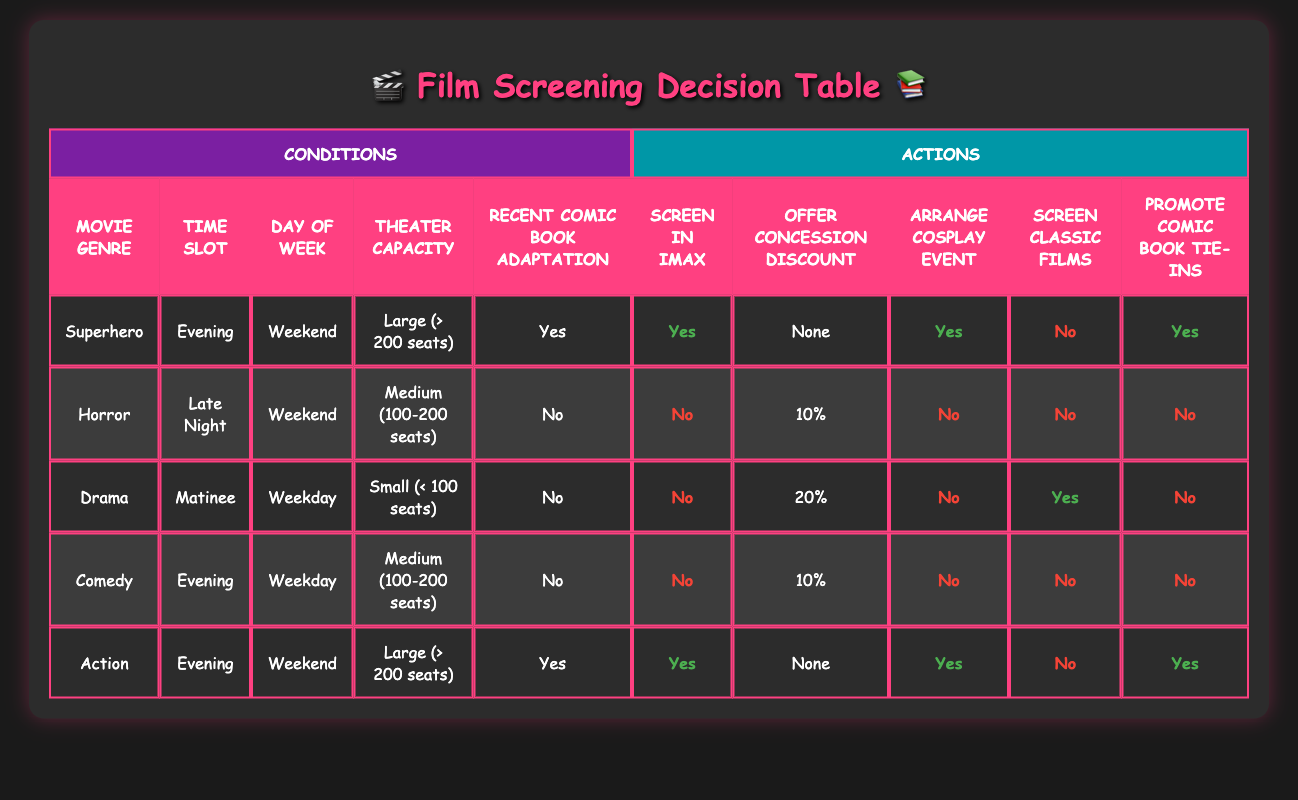What genre of movie is shown in IMAX during the evening on weekends with a recent comic book adaptation? The table shows a row for "Superhero" movies screened in IMAX during the evening on weekends with a recent comic book adaptation. This matches the condition specified in the question.
Answer: Superhero What is the concession discount offered for horror movies screened late at night on weekends? Referring to the row for horror movies, it states that the concession discount offered is 10% for a medium theater capacity and no recent comic book adaptation.
Answer: 10% How many different actions are taken for action movies screened on weekends? The corresponding row for action movies lists four actions: "Screen in IMAX" is Yes, "Offer Concession Discount" is None, "Arrange Cosplay Event" is Yes, and "Promote Comic Book Tie-ins" is Yes. Count these confirmed actions to arrive at the total.
Answer: Four Is there a concession discount offered for drama movies shown during the weekday matinee? Looking at the row for drama movies, it specifies a discount of 20%. Therefore, the answer confirms that there is a concession discount offered.
Answer: Yes What are the conditions for screening classic films during a weekday matinee? Under the conditions for drama movies shown during this time, it is stated that classic films should be screened, which indicates that this condition is satisfied.
Answer: Yes What percentage of the offerings involve screening comic book tie-ins when the movie is an action genre? From the action genre row, it indicates that the screening includes promoting comic book tie-ins. This represents one of the actions out of a total of five actions listed for this genre. Hence the percentage is calculated as (1/5)*100.
Answer: 20% How many genre options match with the action movies under the condition of screening on a weekend, in a large theater? Filtering through the table for rows of action movies that specifically match the conditions provided, we see that there’s only one row that meets these qualifications: the action genre in evening time on weekends at large theaters with recent adaptations. Thus total one match exists.
Answer: One What is the discount for the comedy films screened during weekday evenings? The comedy films row shows that the discount offered is 10% for medium theater capacity during the weekday evening time slot.
Answer: 10% Does the thriller genre appear in the table for the conditions and actions to be taken? Checking through the conditions, there is no mention of a thriller genre anywhere in the table, meaning it does not exist in the dataset provided.
Answer: No 